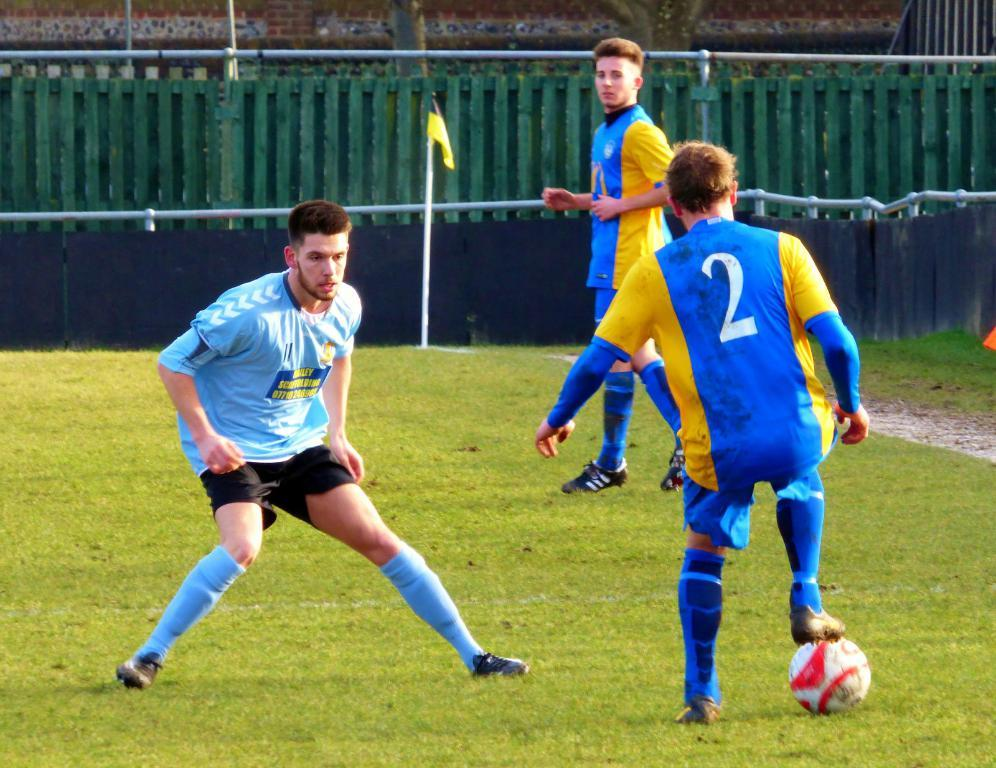Provide a one-sentence caption for the provided image. The young man on the soccer team sponsored by Bailey Scaffolding waits carefully as the number 2 player on the opposing team prepares to kick the ball. 